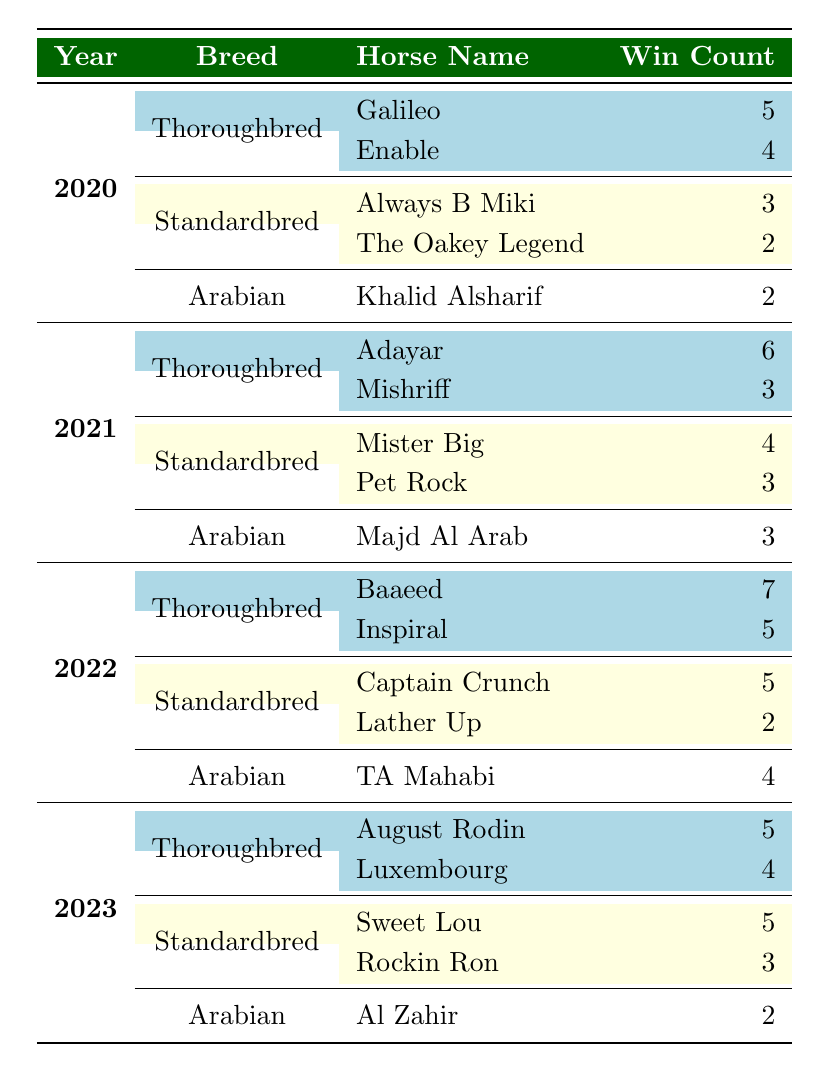What horse had the highest win count in 2022? The table lists "Baaeed" with a win count of 7 under the Thoroughbred breed for the year 2022, which is the highest.
Answer: Baaeed Which breed had more winners in 2023, Thoroughbred or Standardbred? In 2023, Thoroughbred had 2 winners (August Rodin and Luxembourg), while Standardbred also had 2 winners (Sweet Lou and Rockin Ron). Since the number of winners is equal, neither breed had more winners.
Answer: Neither In which year did the Arabian breed have the most win counts and what was the count? Summing the win counts for Arabs for every year: 2020 (2), 2021 (3), 2022 (4), and 2023 (2) shows that 2022 had the highest count of 4.
Answer: 2022, 4 How many more wins did Thoroughbreds have compared to Standardbreds in 2022? The total wins for Thoroughbreds in 2022 are 12 (7 + 5) and for Standardbreds are 7 (5 + 2). The difference between them is 12 - 7 = 5.
Answer: 5 True or False: The horse "Enable" won more races than "Always B Miki" in 2020. Enable had a win count of 4, while Always B Miki had a win count of 3. Therefore, the statement is true.
Answer: True Which Thoroughbred horse had the least wins in 2021 and how many wins did it achieve? In 2021, "Mishriff" had the least wins among Thoroughbreds with a count of 3, while Adayar had a count of 6.
Answer: Mishriff, 3 Combine the win counts of all Standardbred winners from 2020 to 2023. What is the total? The win counts for Standardbreds are: 2020 (5), 2021 (7), 2022 (5), and 2023 (8), which sums to 5 + 7 + 5 + 8 = 25.
Answer: 25 What is the average win count of Thoroughbred winners from 2020 to 2023? The win counts for Thoroughbreds are 5 + 4 + 6 + 3 + 7 + 5 + 5 + 4 = 39. There are 8 contributors, so the average is 39 / 8 = 4.875.
Answer: 4.875 In 2021, how many more wins did the top horse in Thoroughbreds have compared to the top horse in Standardbreds? The top Thoroughbred horse "Adayar" had 6 wins and the top Standardbred "Mister Big" had 4 wins. The difference is 6 - 4 = 2.
Answer: 2 